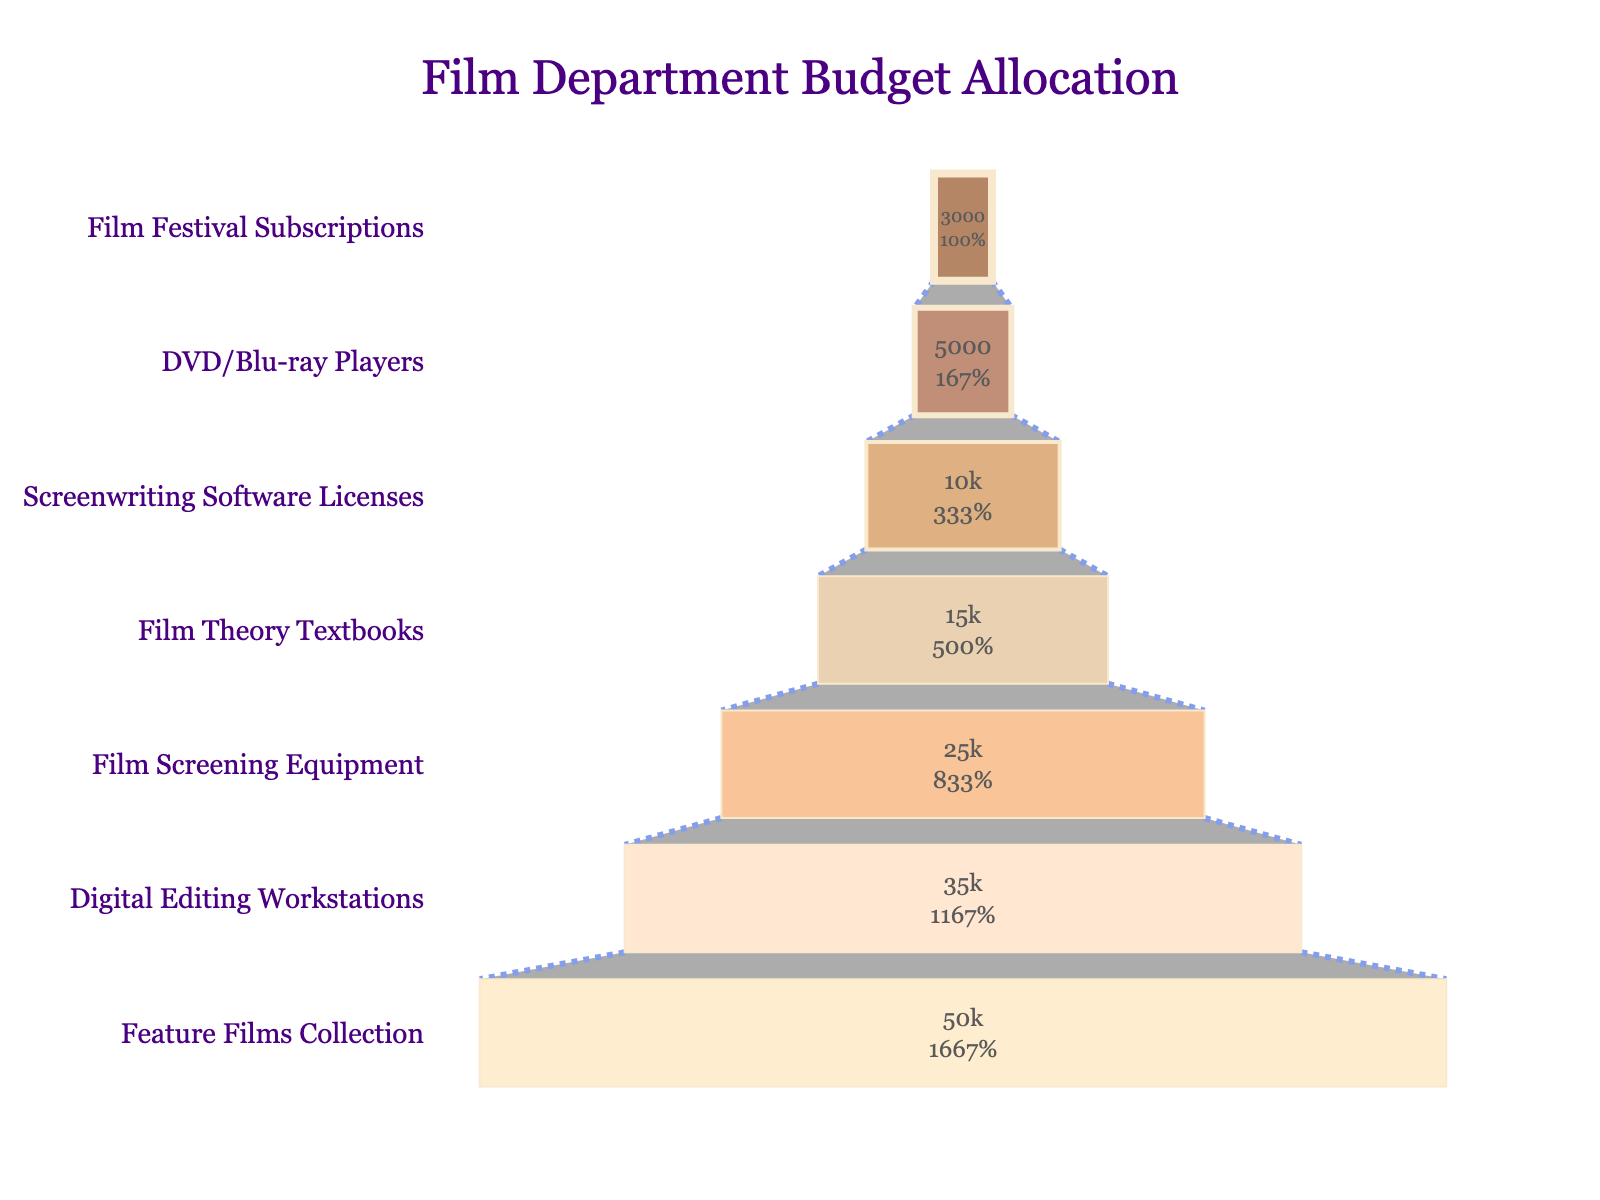what's the category with the highest budget allocation? The highest budget allocation category is the one at the widest part of the funnel. It is labeled at the top.
Answer: Feature Films Collection what's the total budget allocation for the Film Department? Add up all the budget allocations shown in the funnel chart: 50000 + 35000 + 25000 + 15000 + 10000 + 5000 + 3000.
Answer: 138000 which two categories have an equal budget allocation? Identify the two categories that have the same budget allocation amount, which is depicted by the equal width at the corresponding layer of the funnel.
Answer: DVD/Blu-ray Players and Film Festival Subscriptions which category has the smallest budget allocation? The smallest budget allocation category is at the narrowest part of the funnel, usually found at the bottom.
Answer: Film Festival Subscriptions how much more is allocated to Digital Editing Workstations compared to Film Screening Equipment? Subtract the budget allocation for Film Screening Equipment from Digital Editing Workstations. 35000 - 25000.
Answer: 10000 what is the combined budget allocation for Screenwriting Software Licenses and Film Theory Textbooks? Add the budget allocations for Screenwriting Software Licenses and the Film Theory Textbooks: 10000 + 15000.
Answer: 25000 which category is positioned exactly in the middle of the funnel? Identify the category that occupies the middle layer of the funnel chart.
Answer: Film Screening Equipment how much of the total budget is allocated to categories other than Feature Films Collection? Subtract the budget allocation for Feature Films Collection from the total budget: 138000 - 50000.
Answer: 88000 what percentage of the total budget is allocated to Film Theory Textbooks? Divide the budget allocation for Film Theory Textbooks by the total budget and multiply by 100: (15000 / 138000) * 100.
Answer: 10.87% which two categories have budgets within 5000 units of each other? Identify two categories whose budget allocations differ by at most 5000 units.
Answer: Digital Editing Workstations and Film Screening Equipment 